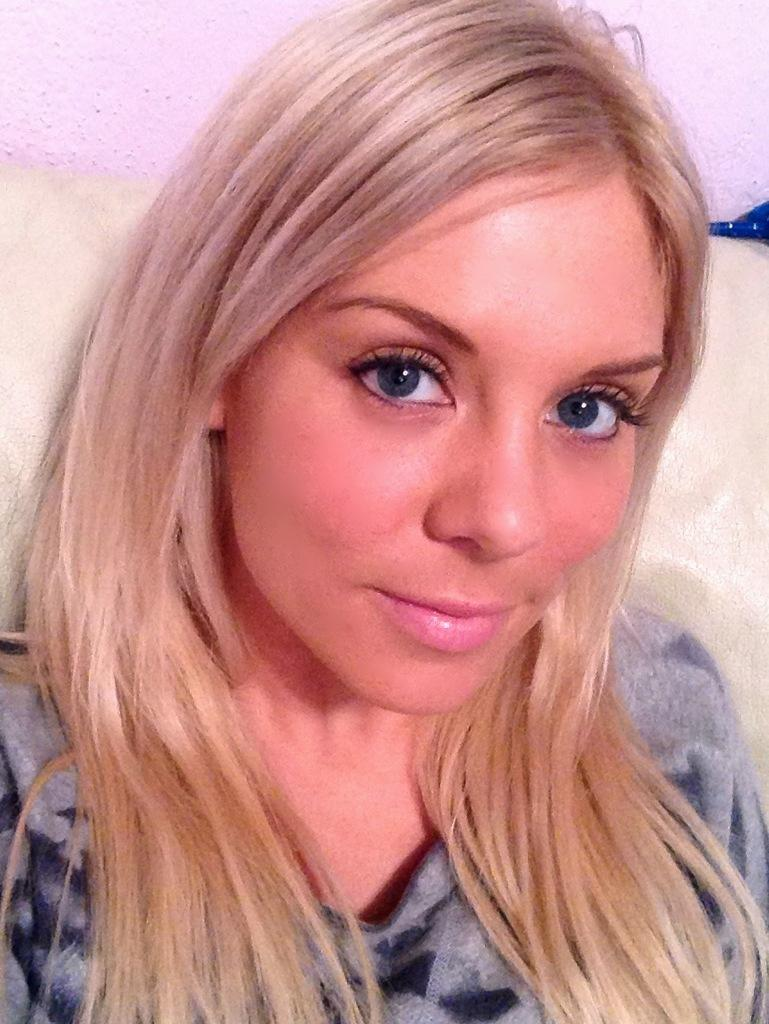Who is present in the image? There is a lady in the image. What expression does the lady have? The lady is smiling. What can be seen in the background of the image? There is a wall in the background of the image. What type of line is visible on the lady's forehead in the image? There is no line visible on the lady's forehead in the image. 